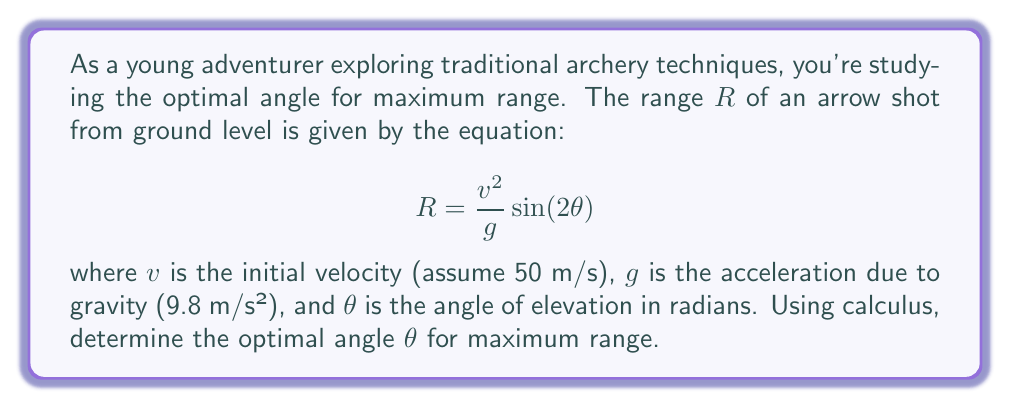Show me your answer to this math problem. To find the optimal angle for maximum range, we need to find the maximum value of the function $R(\theta)$. We can do this by taking the derivative of $R$ with respect to $\theta$ and setting it equal to zero.

1) First, let's simplify our equation by substituting the known values:

   $$R = \frac{50^2}{9.8} \sin(2\theta) = 255.1 \sin(2\theta)$$

2) Now, let's take the derivative of $R$ with respect to $\theta$:

   $$\frac{dR}{d\theta} = 255.1 \cdot 2 \cos(2\theta) = 510.2 \cos(2\theta)$$

3) Set this equal to zero and solve for $\theta$:

   $$510.2 \cos(2\theta) = 0$$
   $$\cos(2\theta) = 0$$

4) The cosine function equals zero when its argument is $\frac{\pi}{2}$ or $\frac{3\pi}{2}$. So:

   $$2\theta = \frac{\pi}{2}$$ or $$2\theta = \frac{3\pi}{2}$$

5) Solving for $\theta$:

   $$\theta = \frac{\pi}{4}$$ or $$\theta = \frac{3\pi}{4}$$

6) To determine which of these gives a maximum (rather than a minimum), we can check the second derivative:

   $$\frac{d^2R}{d\theta^2} = 510.2 \cdot (-2\sin(2\theta))$$

   At $\theta = \frac{\pi}{4}$, this is negative, indicating a maximum.

7) Convert radians to degrees:

   $$\frac{\pi}{4} \text{ radians} = 45°$$

Therefore, the optimal angle for maximum range is 45°.
Answer: The optimal angle for maximum range in traditional archery is 45°. 